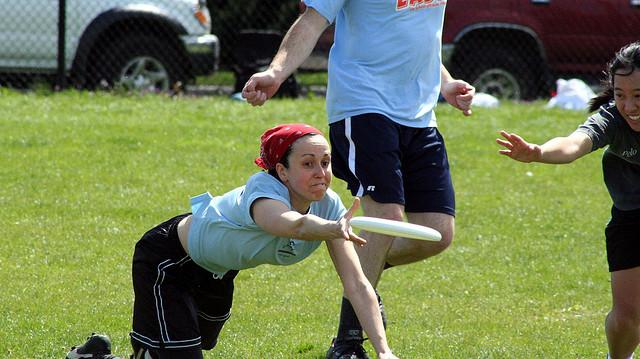What is the woman ready to do?

Choices:
A) catch
B) roll
C) run
D) eat catch 